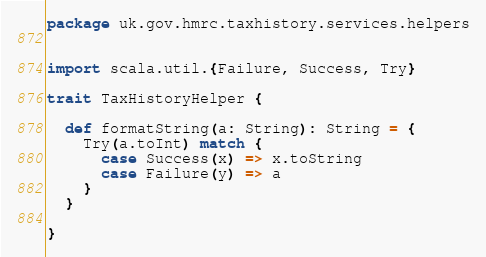Convert code to text. <code><loc_0><loc_0><loc_500><loc_500><_Scala_>package uk.gov.hmrc.taxhistory.services.helpers


import scala.util.{Failure, Success, Try}

trait TaxHistoryHelper {

  def formatString(a: String): String = {
    Try(a.toInt) match {
      case Success(x) => x.toString
      case Failure(y) => a
    }
  }

}</code> 